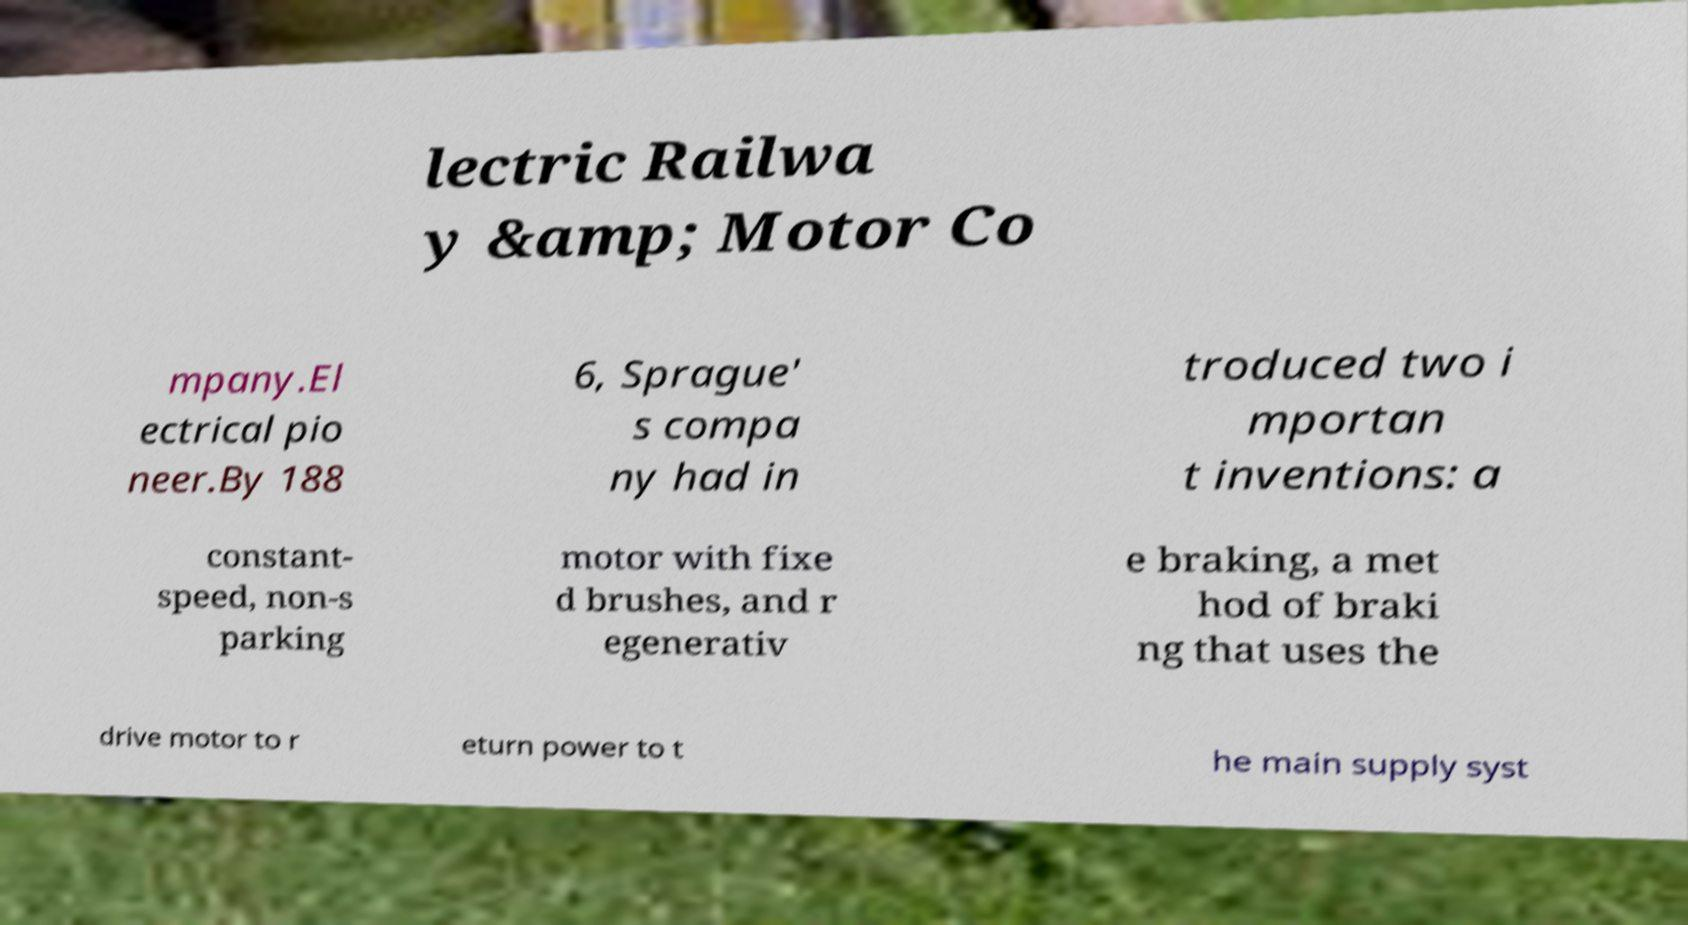For documentation purposes, I need the text within this image transcribed. Could you provide that? lectric Railwa y &amp; Motor Co mpany.El ectrical pio neer.By 188 6, Sprague' s compa ny had in troduced two i mportan t inventions: a constant- speed, non-s parking motor with fixe d brushes, and r egenerativ e braking, a met hod of braki ng that uses the drive motor to r eturn power to t he main supply syst 